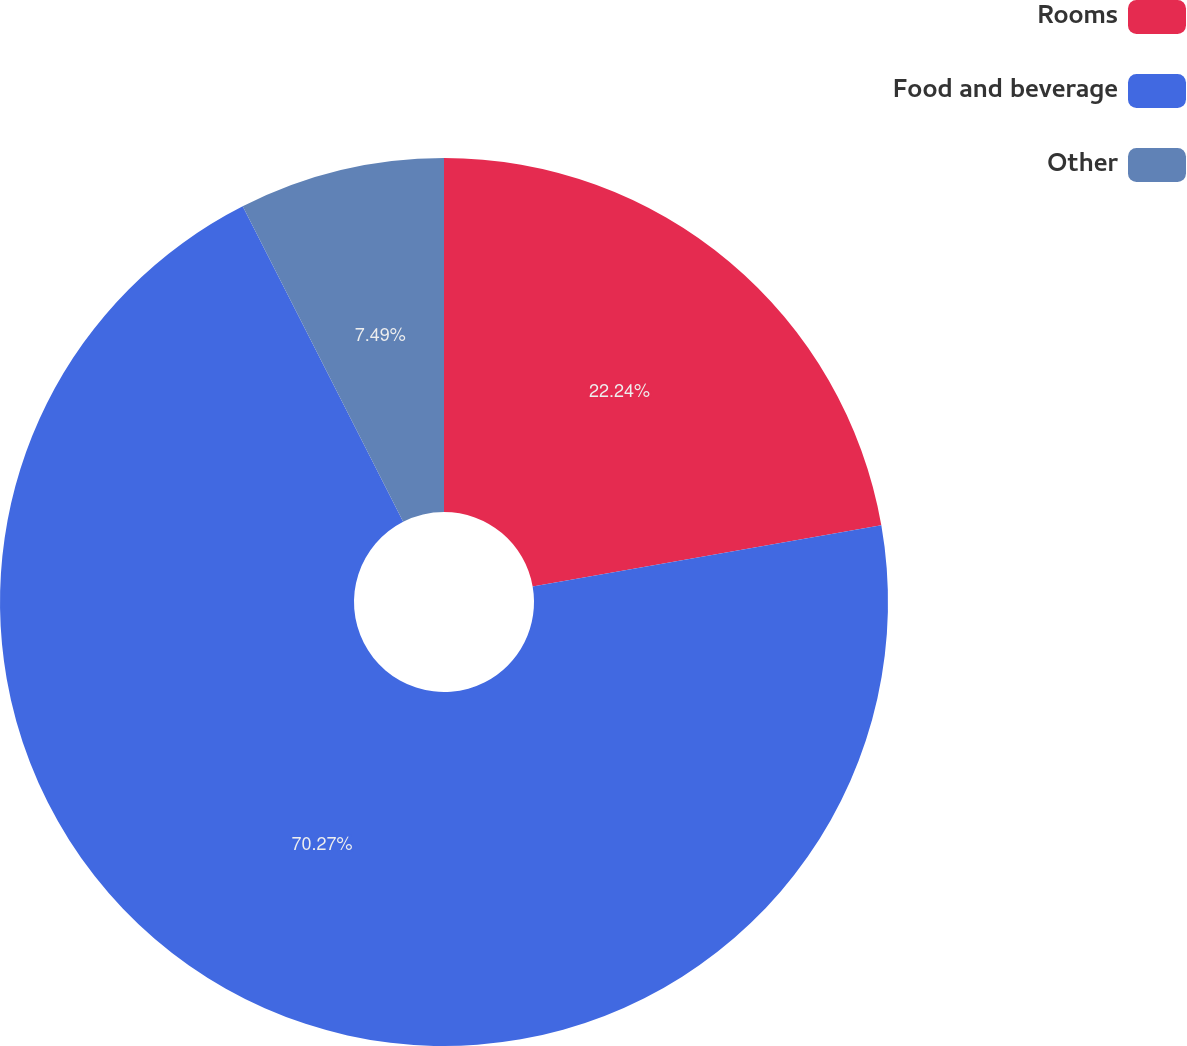<chart> <loc_0><loc_0><loc_500><loc_500><pie_chart><fcel>Rooms<fcel>Food and beverage<fcel>Other<nl><fcel>22.24%<fcel>70.28%<fcel>7.49%<nl></chart> 